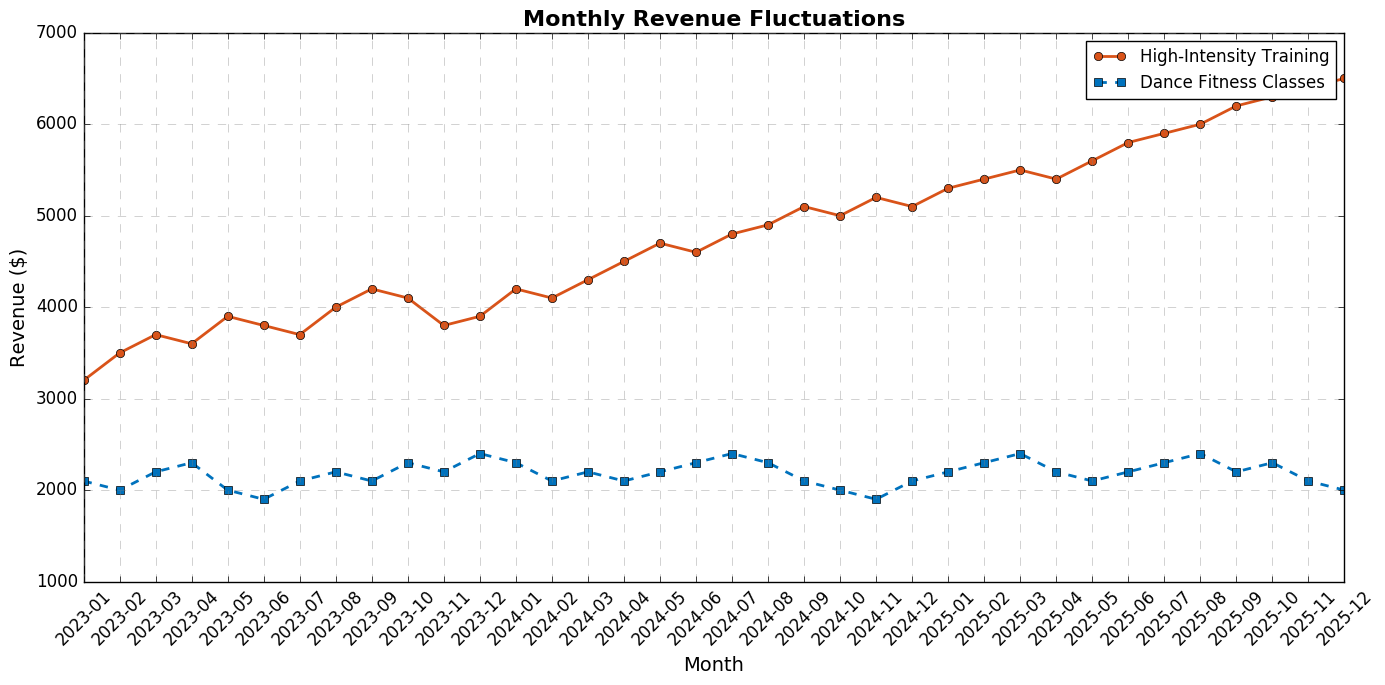What's the highest revenue value achieved by High-Intensity Training programs? Look at the line representing High-Intensity Training; the peak value is at the end of the timeline for December 2025, which is 6500 dollars.
Answer: 6500 dollars Which month shows the largest revenue difference between High-Intensity Training and Dance Fitness Classes? Identify the month with the biggest gap between the two lines; in December 2025, High-Intensity Training is at 6500 dollars while Dance Fitness Classes are at 2000 dollars, resulting in a 4500 dollar difference.
Answer: December 2025 What was the overall revenue trend for Dance Fitness Classes from January 2023 to December 2025? Observe the general direction of the Dance Fitness Classes line; it starts around 2100 dollars in January 2023 and does not significantly increase, hovering around the 2000 to 2400 dollar range.
Answer: Flat and relatively stable In which month did both programs experience a revenue peak simultaneously? Notice the peaks of both lines and find where they coincide; in January 2024, both are not at their peaks. Another check shows no same-month peaks.
Answer: None How does the revenue for High-Intensity Training in July 2025 compare to that in July 2023? Identify July points for both years and compare; it was 3700 dollars in July 2023 and increased to 5900 dollars in July 2025.
Answer: July 2025 is higher by 2200 dollars Calculate the average revenue for High-Intensity Training in 2024. Sum the monthly revenues for 2024 and divide by 12: (4200 + 4100 + 4300 + 4500 + 4700 + 4600 + 4800 + 4900 + 5100 + 5000 + 5200 + 5100) = 55500, then 55500/12 ≈ 4625 dollars.
Answer: 4625 dollars Which program had a more consistent revenue stream based on visual inspection, and why? Observe the range and fluctuations of both lines; Dance Fitness Classes have less variation and a narrower range while High-Intensity Training shows a growing trend and more fluctuations.
Answer: Dance Fitness Classes, less variation How much did the revenue for High-Intensity Training programs increase from the start to the end of the plotted period? Subtract the first month’s revenue from the last month: 6500 dollars in December 2025 - 3200 dollars in January 2023 = 3300 dollars.
Answer: 3300 dollars What is the minimum revenue recorded for Dance Fitness Classes during the period? Check the lowest points on the Dance Fitness Classes line; the lowest value is 1900 dollars, especially noticeable in June 2023 and November 2024.
Answer: 1900 dollars Was there any decline in High-Intensity Training revenue within a single year, and if so, in which months? Look for any downward trend segments on the High-Intensity Training line; for example, in 2023, from March (3700 dollars) to April (3600 dollars).
Answer: March to April 2023 